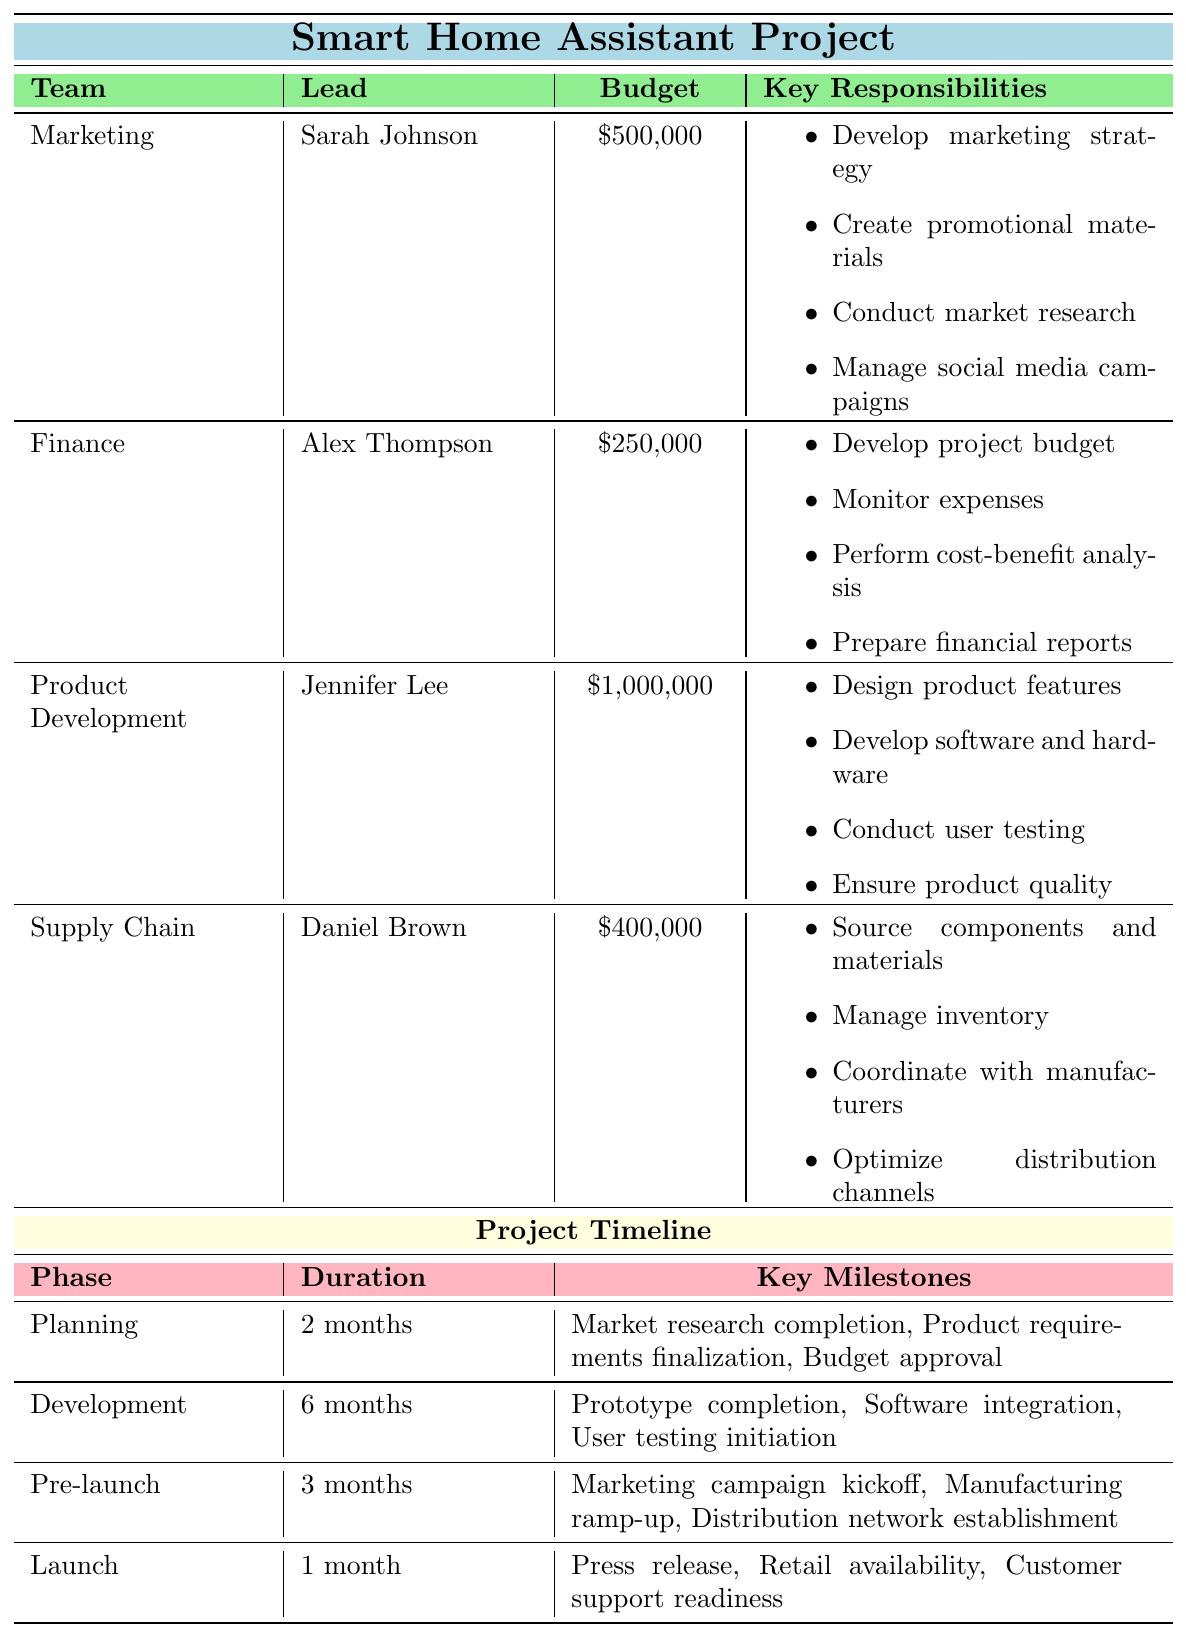What is the budget allocation for the Product Development team? The table states that the Product Development team has a budget allocation of $1,000,000.
Answer: $1,000,000 Who is the team lead of the Supply Chain team? According to the table, Daniel Brown is listed as the team lead of the Supply Chain team.
Answer: Daniel Brown Which team has the highest budget allocation? By comparing the budget allocations listed in the table, the Product Development team has the highest allocation at $1,000,000.
Answer: Product Development How many team members are allocated 100% of their time to the Product Development team? The table shows that there are three members in the Product Development team: Thomas Schmidt, Ryan Cooper, and Olivia Martinez, all with 100% time allocation.
Answer: 3 What are the key responsibilities of the Marketing team? The table specifies that the Marketing team has several responsibilities, including developing marketing strategy and managing social media campaigns.
Answer: Develop marketing strategy, create promotional materials, conduct market research, manage social media campaigns Is there a team member in the Finance team who has less than 80% time allocation? The table confirms that Lisa Wong has a time allocation of 70%, which is less than 80%.
Answer: Yes What is the total budget for all teams combined? Adding the budget allocations: $500,000 (Marketing) + $250,000 (Finance) + $1,000,000 (Product Development) + $400,000 (Supply Chain) gives a total of $2,150,000.
Answer: $2,150,000 Which phase has the longest duration in the project timeline? The table indicates that the Development phase has a duration of 6 months, which is the longest compared to other phases.
Answer: Development Are there any team members with the same role in different teams? By reviewing the table, there is no mention of identical roles across different teams. Thus, this statement is false.
Answer: No What percentage of time is allocated collectively by team members in the Finance team? The Finance team consists of two members, with one at 70% and the other at 100%. Summing these percentages gives 70% + 100% = 170%.
Answer: 170% 